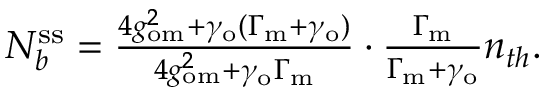<formula> <loc_0><loc_0><loc_500><loc_500>\begin{array} { r } { N _ { b } ^ { s s } = \frac { 4 g _ { o m } ^ { 2 } + \gamma _ { o } ( \Gamma _ { m } + \gamma _ { o } ) } { 4 g _ { o m } ^ { 2 } + \gamma _ { o } \Gamma _ { m } } \cdot \frac { \Gamma _ { m } } { \Gamma _ { m } + \gamma _ { o } } n _ { t h } . } \end{array}</formula> 